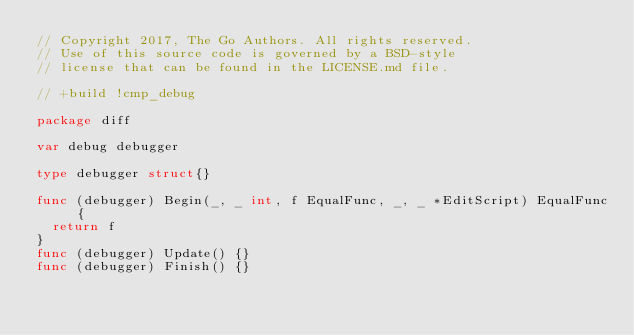<code> <loc_0><loc_0><loc_500><loc_500><_Go_>// Copyright 2017, The Go Authors. All rights reserved.
// Use of this source code is governed by a BSD-style
// license that can be found in the LICENSE.md file.

// +build !cmp_debug

package diff

var debug debugger

type debugger struct{}

func (debugger) Begin(_, _ int, f EqualFunc, _, _ *EditScript) EqualFunc {
	return f
}
func (debugger) Update() {}
func (debugger) Finish() {}
</code> 